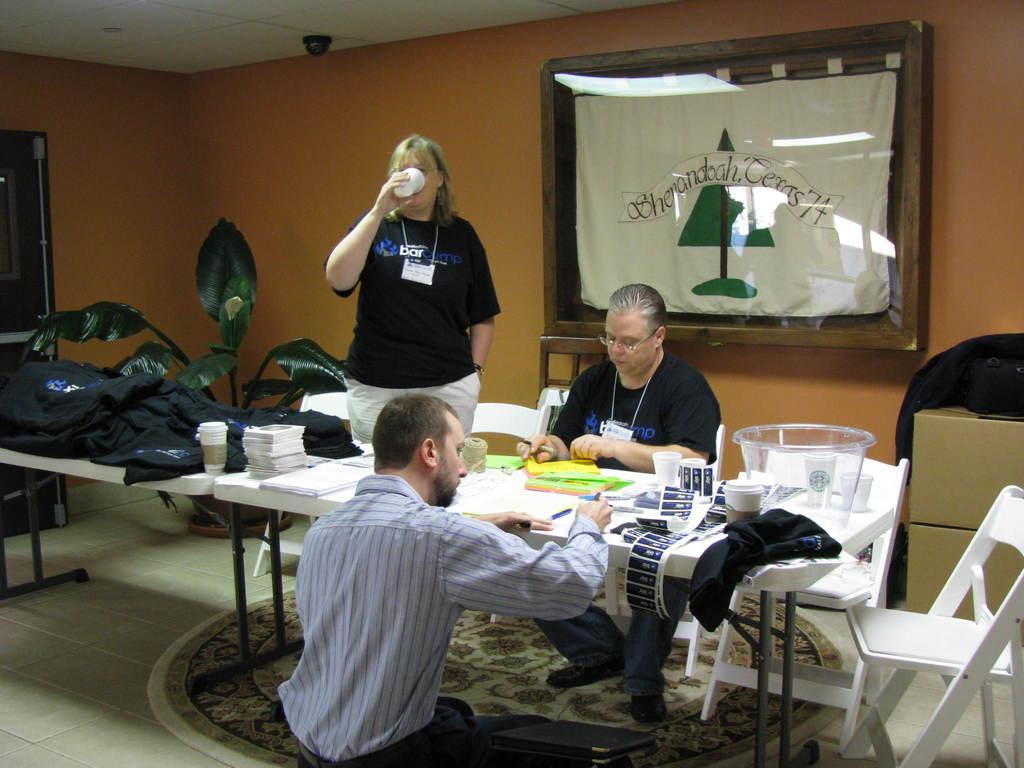Describe this image in one or two sentences. In this image there is a woman standing and holding a glass is wearing a black shirt and white pant. There is a person sitting on a chair is wearing a black shirt. There is a person sitting on ground before a table. On table there are bags, cup, papers, pen, cloth, bowl on it. At the right side there are two chairs. Frame is attached to the wall. There is a plant at the left side of image. 